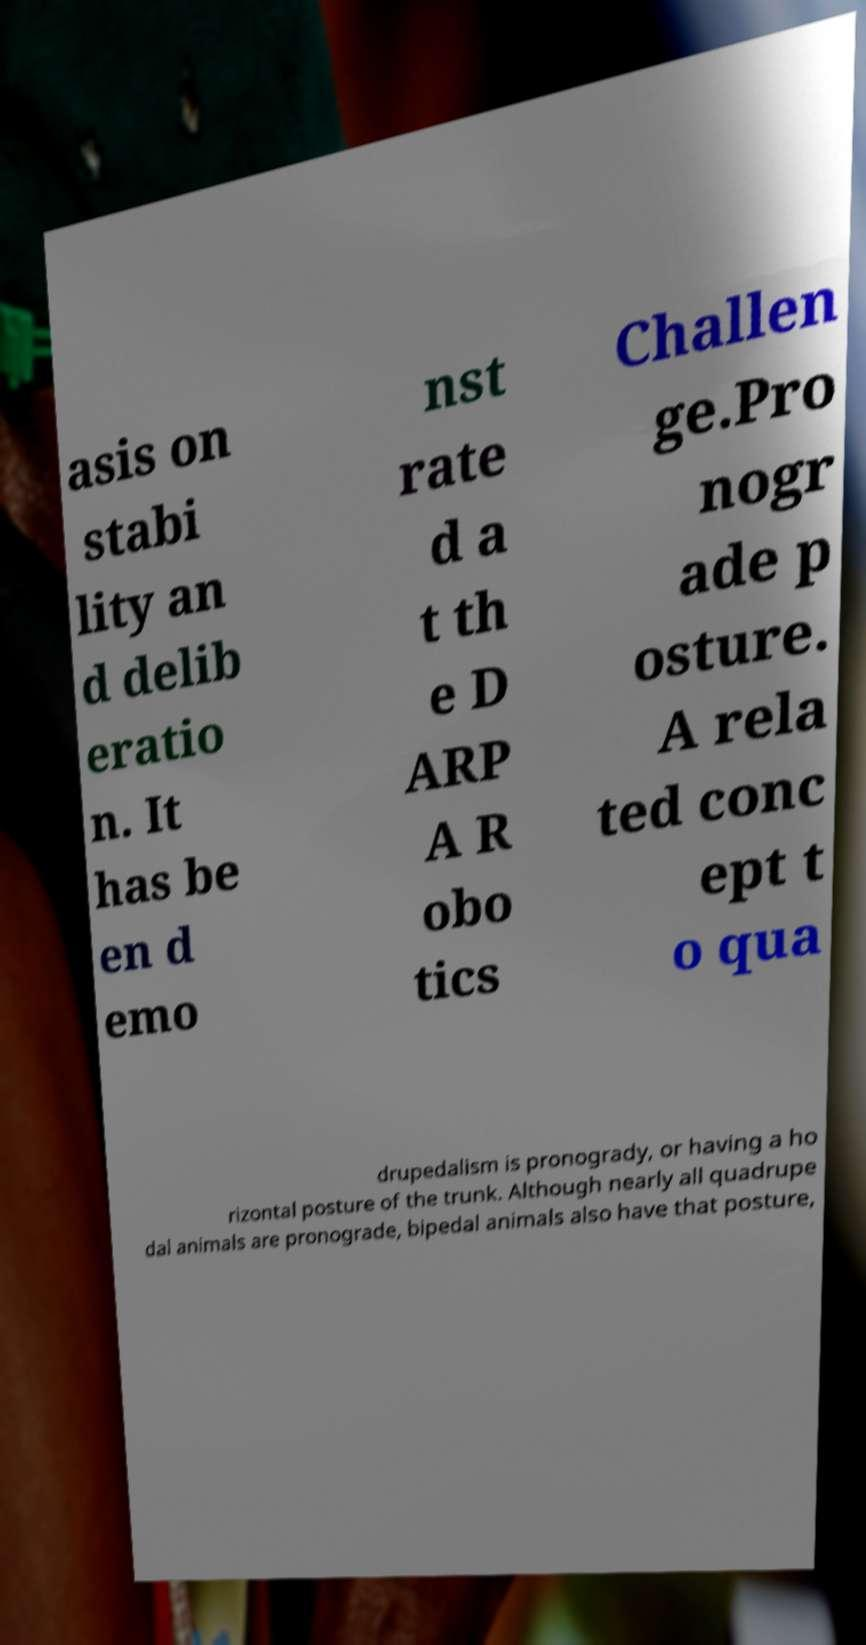For documentation purposes, I need the text within this image transcribed. Could you provide that? asis on stabi lity an d delib eratio n. It has be en d emo nst rate d a t th e D ARP A R obo tics Challen ge.Pro nogr ade p osture. A rela ted conc ept t o qua drupedalism is pronogrady, or having a ho rizontal posture of the trunk. Although nearly all quadrupe dal animals are pronograde, bipedal animals also have that posture, 